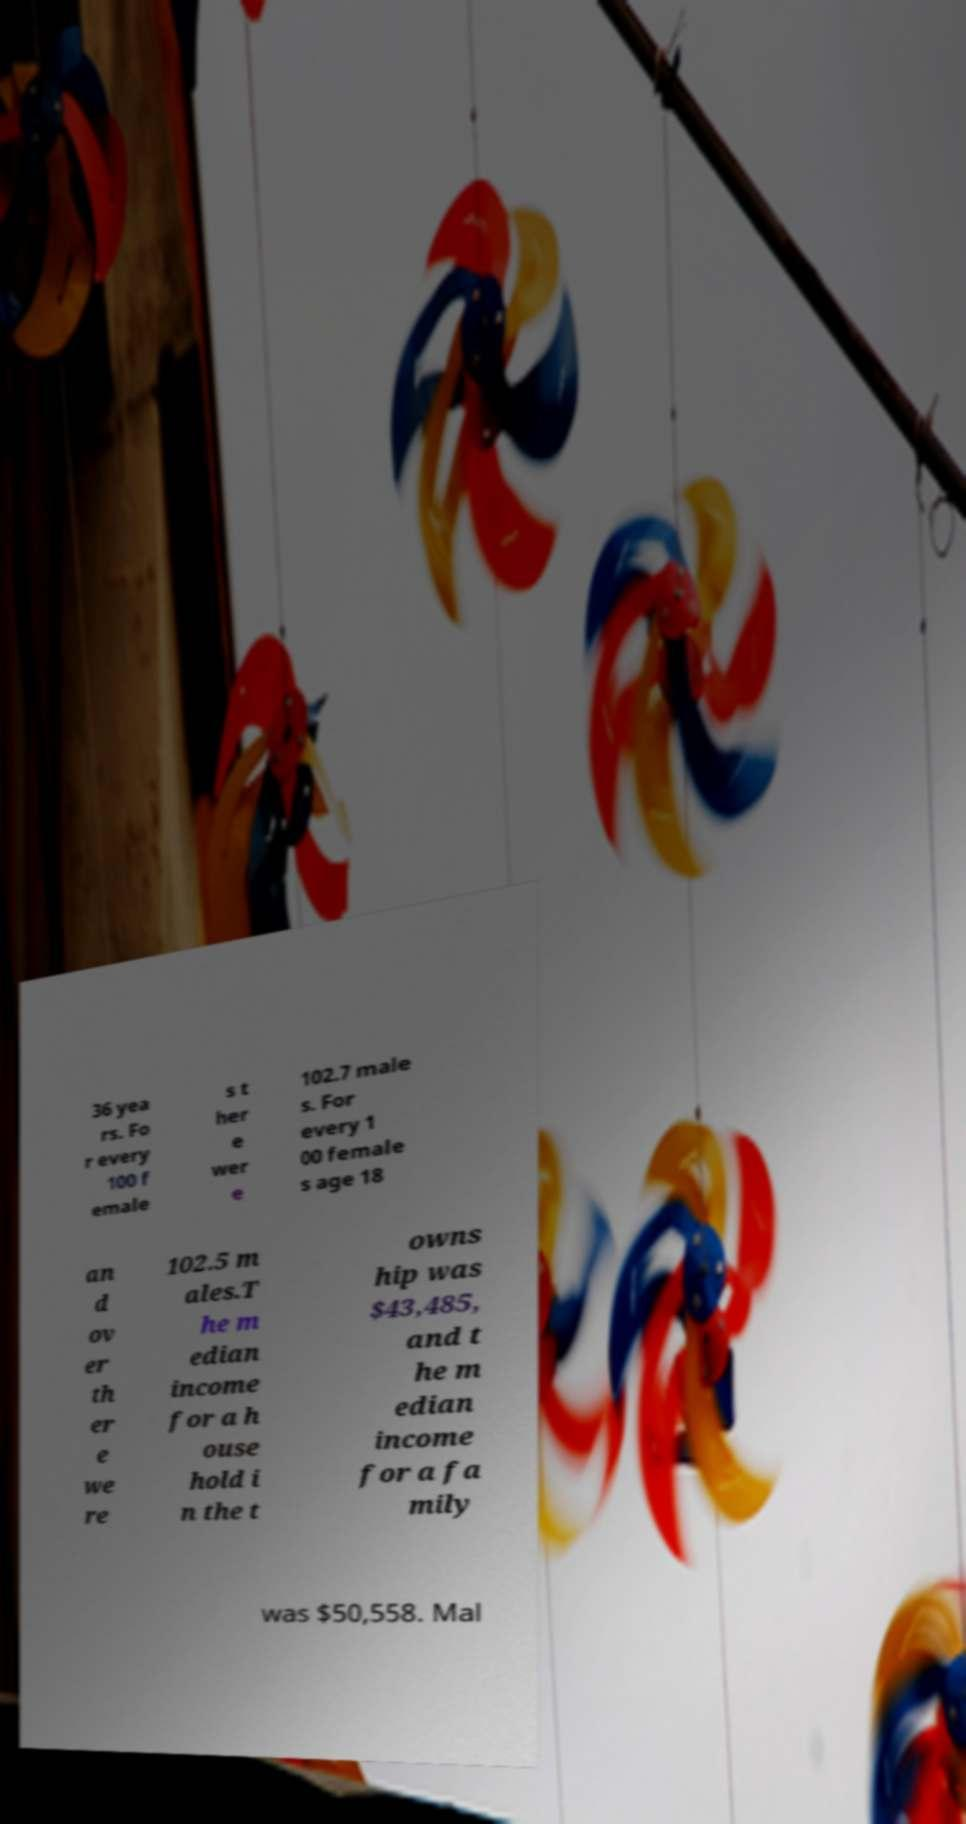I need the written content from this picture converted into text. Can you do that? 36 yea rs. Fo r every 100 f emale s t her e wer e 102.7 male s. For every 1 00 female s age 18 an d ov er th er e we re 102.5 m ales.T he m edian income for a h ouse hold i n the t owns hip was $43,485, and t he m edian income for a fa mily was $50,558. Mal 